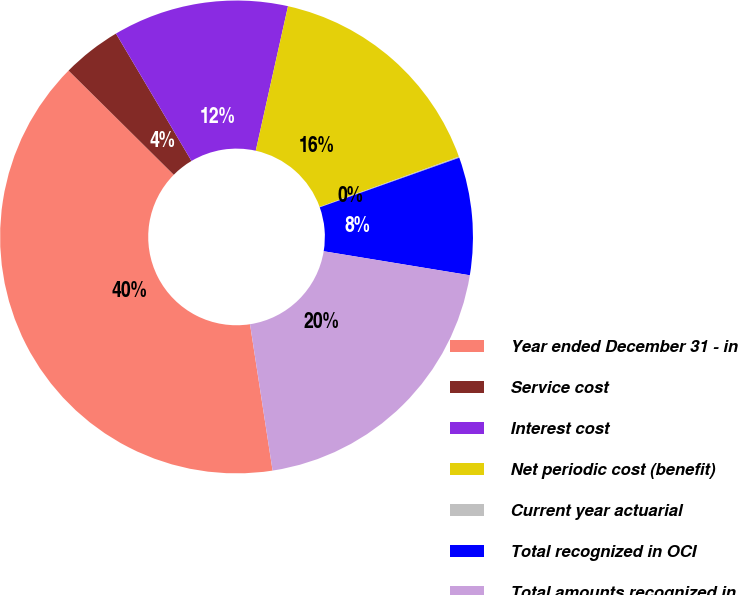Convert chart. <chart><loc_0><loc_0><loc_500><loc_500><pie_chart><fcel>Year ended December 31 - in<fcel>Service cost<fcel>Interest cost<fcel>Net periodic cost (benefit)<fcel>Current year actuarial<fcel>Total recognized in OCI<fcel>Total amounts recognized in<nl><fcel>39.86%<fcel>4.06%<fcel>12.01%<fcel>15.99%<fcel>0.08%<fcel>8.03%<fcel>19.97%<nl></chart> 